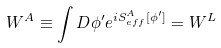Convert formula to latex. <formula><loc_0><loc_0><loc_500><loc_500>W ^ { A } \equiv \int D \phi ^ { \prime } e ^ { i S _ { e f f } ^ { A } [ \phi ^ { \prime } ] } = W ^ { L }</formula> 